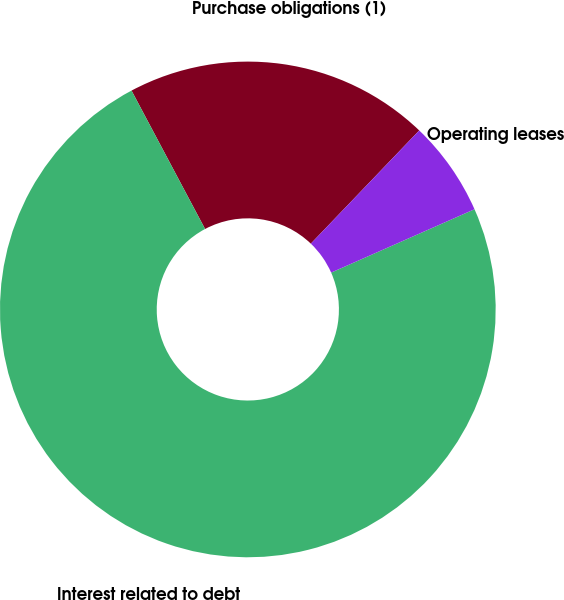Convert chart to OTSL. <chart><loc_0><loc_0><loc_500><loc_500><pie_chart><fcel>Purchase obligations (1)<fcel>Interest related to debt<fcel>Operating leases<nl><fcel>19.93%<fcel>73.85%<fcel>6.22%<nl></chart> 